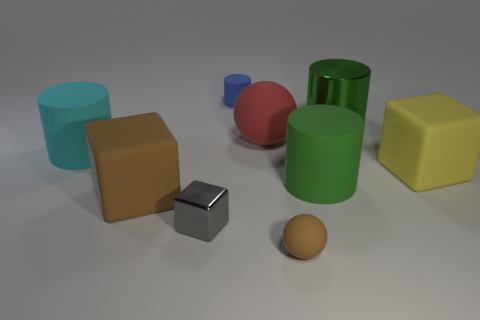Add 1 green matte cylinders. How many objects exist? 10 Subtract all brown spheres. How many spheres are left? 1 Subtract all small gray blocks. How many blocks are left? 2 Subtract 0 gray balls. How many objects are left? 9 Subtract all balls. How many objects are left? 7 Subtract 1 blocks. How many blocks are left? 2 Subtract all brown cylinders. Subtract all blue cubes. How many cylinders are left? 4 Subtract all cyan balls. How many yellow cylinders are left? 0 Subtract all green metallic cubes. Subtract all large yellow matte cubes. How many objects are left? 8 Add 5 cyan cylinders. How many cyan cylinders are left? 6 